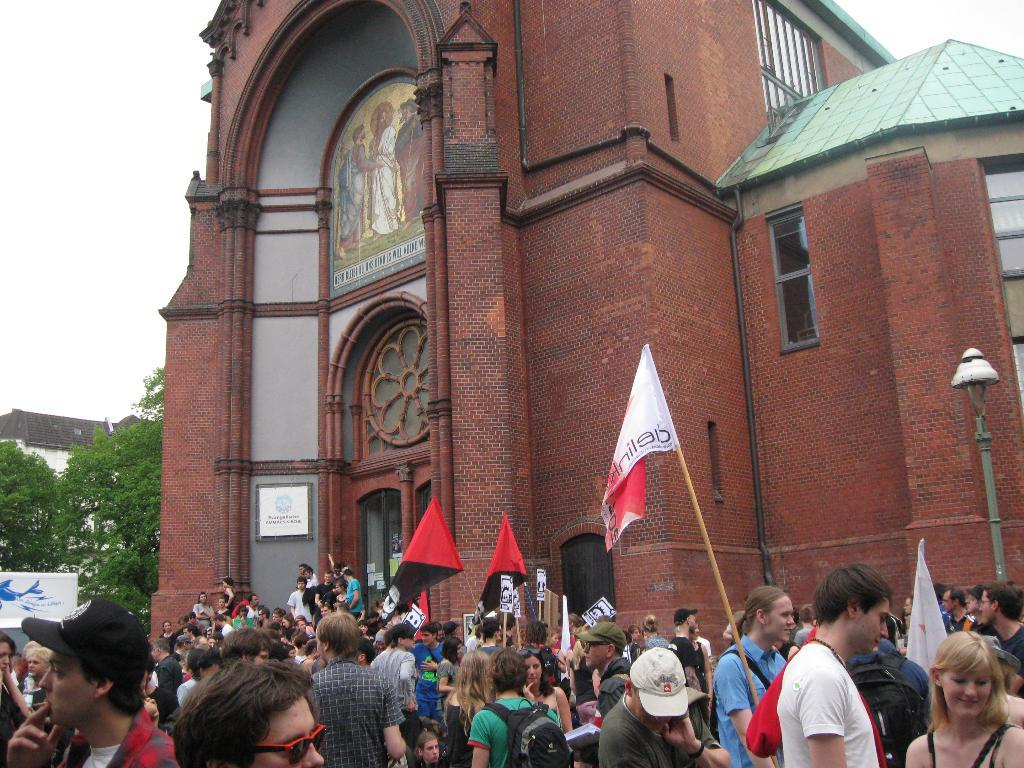How many people are in the image? There is a group of people in the image, but the exact number is not specified. What can be seen besides the people in the image? There are flags, buildings, trees, and some objects in the image. What is visible in the background of the image? The sky is visible in the background of the image. What type of bait is being used by the achiever in the image? There is no achiever or bait present in the image. 